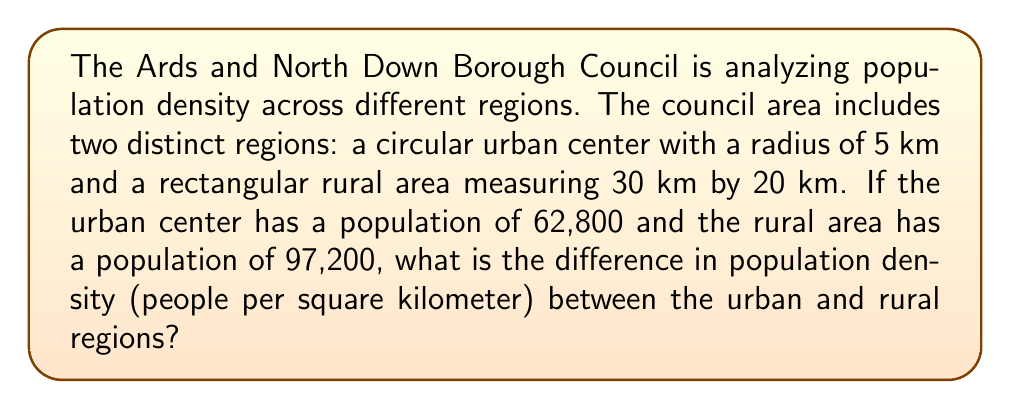Can you solve this math problem? To solve this problem, we need to follow these steps:

1. Calculate the area of the urban center (circle):
   $$A_{urban} = \pi r^2 = \pi \cdot 5^2 = 25\pi \approx 78.54 \text{ km}^2$$

2. Calculate the area of the rural region (rectangle):
   $$A_{rural} = l \cdot w = 30 \cdot 20 = 600 \text{ km}^2$$

3. Calculate the population density of the urban center:
   $$\text{Density}_{urban} = \frac{\text{Population}_{urban}}{A_{urban}} = \frac{62,800}{25\pi} \approx 799.68 \text{ people/km}^2$$

4. Calculate the population density of the rural area:
   $$\text{Density}_{rural} = \frac{\text{Population}_{rural}}{A_{rural}} = \frac{97,200}{600} = 162 \text{ people/km}^2$$

5. Calculate the difference in population density:
   $$\text{Difference} = \text{Density}_{urban} - \text{Density}_{rural} \approx 799.68 - 162 = 637.68 \text{ people/km}^2$$
Answer: 637.68 people/km² 